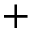<formula> <loc_0><loc_0><loc_500><loc_500>^ { + }</formula> 